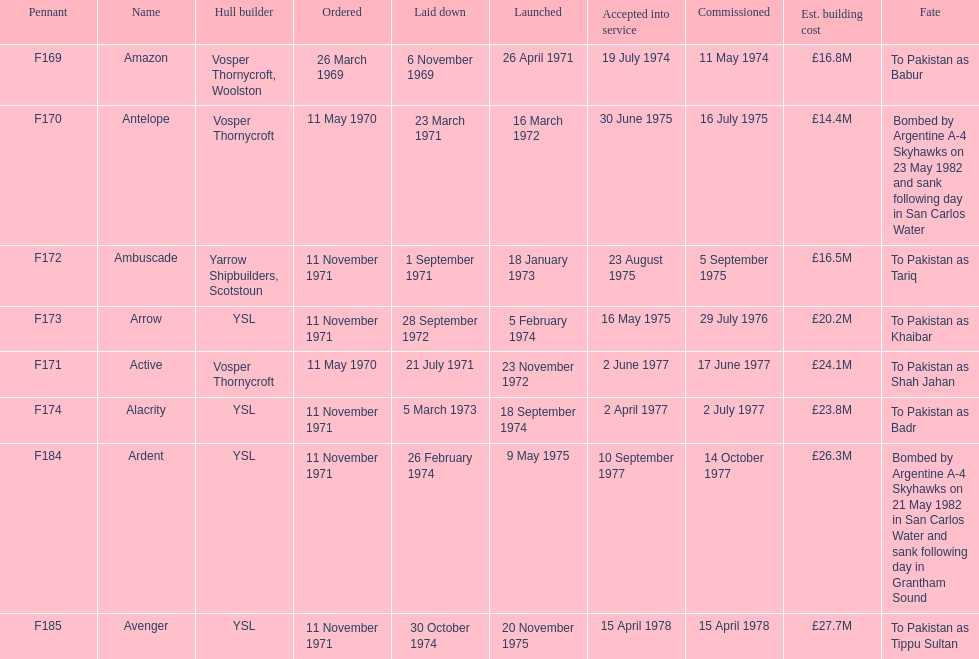What is the subsequent pennant following f172? F173. 